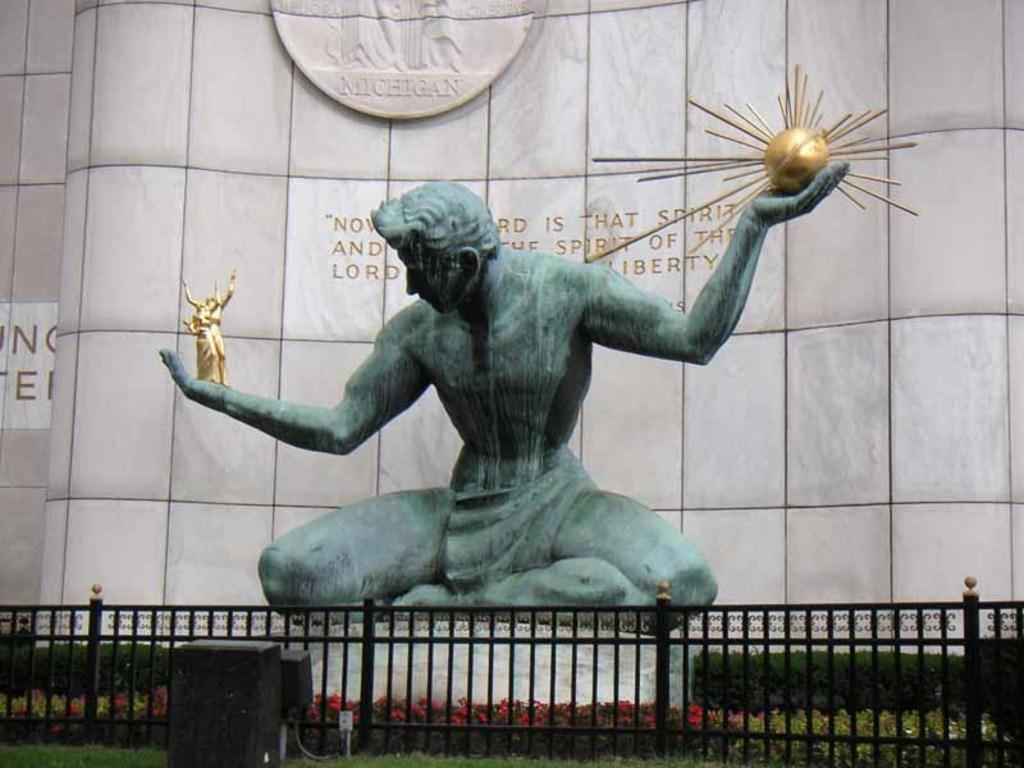What is the main subject in the image? There is a statue in the image. What can be seen around the statue? There are flowers and plants in the image. What type of barrier is present in the image? There is fencing in the image. What else can be seen in the image besides the statue and plants? There are objects in the image. Is there any text or writing in the image? Yes, there is something written on a white surface in the image. How does the fog affect the visibility of the statue in the image? There is no fog present in the image, so it does not affect the visibility of the statue. 